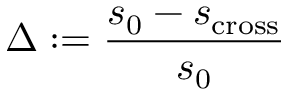<formula> <loc_0><loc_0><loc_500><loc_500>\Delta \colon = \frac { s _ { 0 } - s _ { c r o s s } } { s _ { 0 } }</formula> 